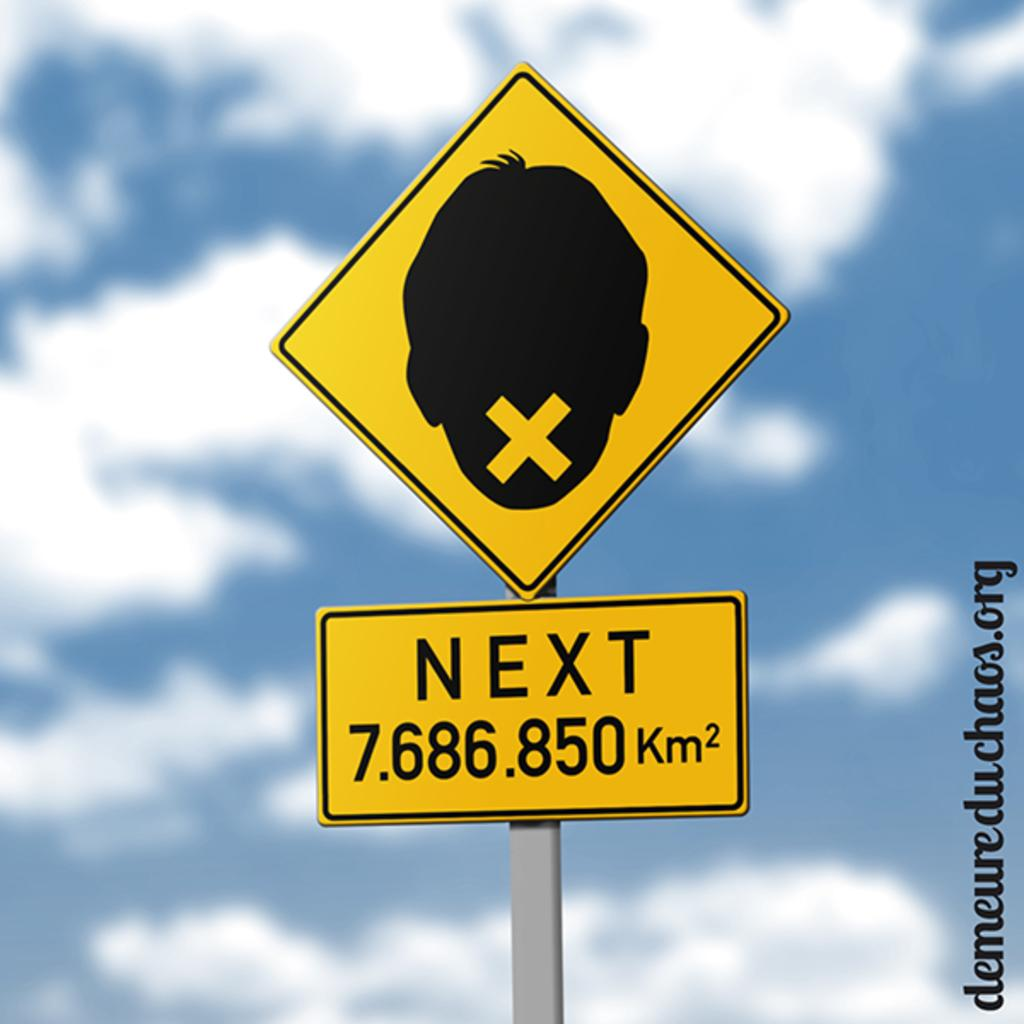<image>
Offer a succinct explanation of the picture presented. Sign with a person's face and the word "NEXT" on it. 